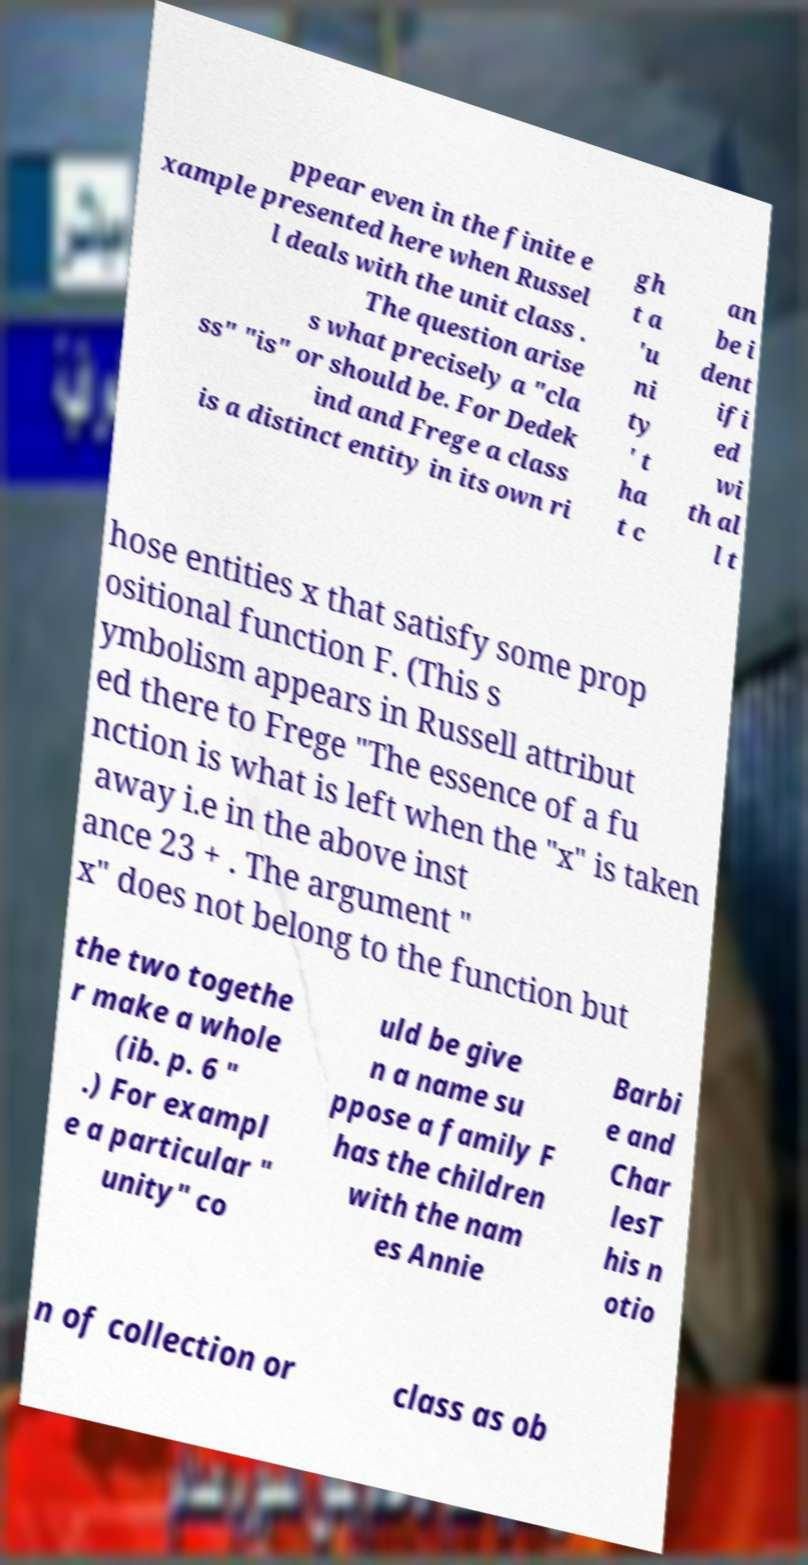Could you assist in decoding the text presented in this image and type it out clearly? ppear even in the finite e xample presented here when Russel l deals with the unit class . The question arise s what precisely a "cla ss" "is" or should be. For Dedek ind and Frege a class is a distinct entity in its own ri gh t a 'u ni ty ' t ha t c an be i dent ifi ed wi th al l t hose entities x that satisfy some prop ositional function F. (This s ymbolism appears in Russell attribut ed there to Frege "The essence of a fu nction is what is left when the "x" is taken away i.e in the above inst ance 23 + . The argument " x" does not belong to the function but the two togethe r make a whole (ib. p. 6 " .) For exampl e a particular " unity" co uld be give n a name su ppose a family F has the children with the nam es Annie Barbi e and Char lesT his n otio n of collection or class as ob 